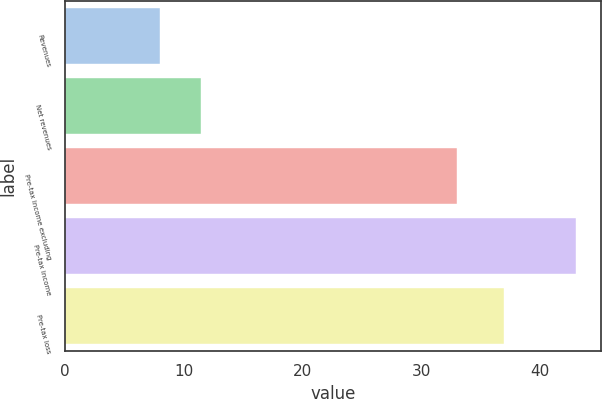Convert chart. <chart><loc_0><loc_0><loc_500><loc_500><bar_chart><fcel>Revenues<fcel>Net revenues<fcel>Pre-tax income excluding<fcel>Pre-tax income<fcel>Pre-tax loss<nl><fcel>8<fcel>11.5<fcel>33<fcel>43<fcel>37<nl></chart> 